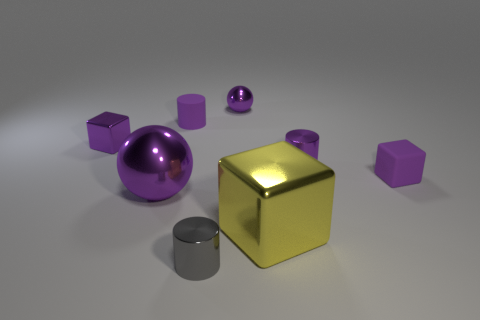Is the small metal block the same color as the big sphere?
Give a very brief answer. Yes. What number of spheres are there?
Your answer should be very brief. 2. What number of metallic cubes are the same color as the small matte cube?
Offer a very short reply. 1. There is a purple shiny object that is behind the small purple rubber cylinder; is its shape the same as the purple rubber object that is right of the tiny purple metal sphere?
Your answer should be compact. No. There is a rubber thing that is on the left side of the tiny purple block that is on the right side of the tiny cube on the left side of the tiny gray cylinder; what is its color?
Offer a terse response. Purple. What is the color of the block behind the small rubber block?
Provide a succinct answer. Purple. There is another block that is the same size as the rubber cube; what is its color?
Provide a succinct answer. Purple. Is the gray metallic cylinder the same size as the rubber cylinder?
Keep it short and to the point. Yes. How many metal spheres are to the left of the tiny purple shiny ball?
Your answer should be compact. 1. What number of things are metallic things that are in front of the big purple object or purple metallic objects?
Keep it short and to the point. 6. 